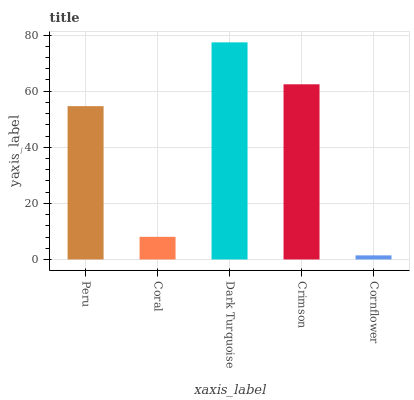Is Coral the minimum?
Answer yes or no. No. Is Coral the maximum?
Answer yes or no. No. Is Peru greater than Coral?
Answer yes or no. Yes. Is Coral less than Peru?
Answer yes or no. Yes. Is Coral greater than Peru?
Answer yes or no. No. Is Peru less than Coral?
Answer yes or no. No. Is Peru the high median?
Answer yes or no. Yes. Is Peru the low median?
Answer yes or no. Yes. Is Cornflower the high median?
Answer yes or no. No. Is Coral the low median?
Answer yes or no. No. 